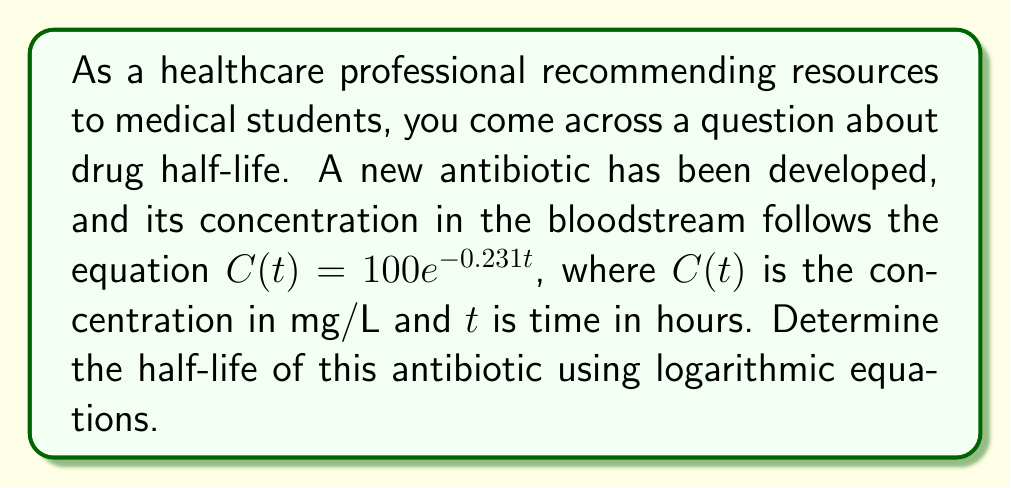Provide a solution to this math problem. To solve this problem, we'll use the properties of logarithms and the definition of half-life:

1) The half-life is the time it takes for the concentration to reduce to half its initial value. Let's call this time $t_{1/2}$.

2) At $t = 0$, the initial concentration is 100 mg/L.
   At $t = t_{1/2}$, the concentration will be 50 mg/L.

3) We can set up the equation:
   $$50 = 100e^{-0.231t_{1/2}}$$

4) Divide both sides by 100:
   $$\frac{1}{2} = e^{-0.231t_{1/2}}$$

5) Take the natural logarithm of both sides:
   $$\ln(\frac{1}{2}) = \ln(e^{-0.231t_{1/2}})$$

6) Simplify the right side using the property of logarithms:
   $$\ln(\frac{1}{2}) = -0.231t_{1/2}$$

7) Solve for $t_{1/2}$:
   $$t_{1/2} = \frac{\ln(\frac{1}{2})}{-0.231}$$

8) Calculate:
   $$t_{1/2} = \frac{-0.693}{-0.231} \approx 3.00 \text{ hours}$$

The half-life of the antibiotic is approximately 3.00 hours.
Answer: The half-life of the antibiotic is approximately 3.00 hours. 